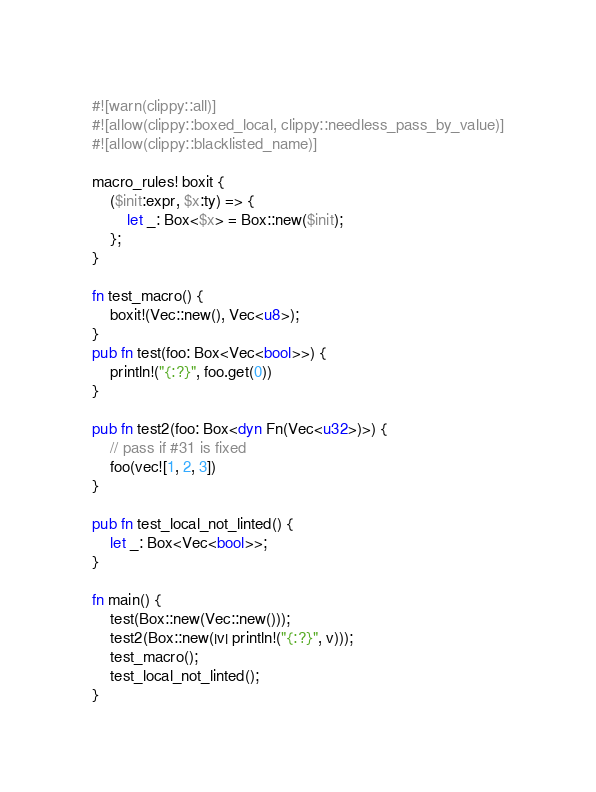Convert code to text. <code><loc_0><loc_0><loc_500><loc_500><_Rust_>#![warn(clippy::all)]
#![allow(clippy::boxed_local, clippy::needless_pass_by_value)]
#![allow(clippy::blacklisted_name)]

macro_rules! boxit {
    ($init:expr, $x:ty) => {
        let _: Box<$x> = Box::new($init);
    };
}

fn test_macro() {
    boxit!(Vec::new(), Vec<u8>);
}
pub fn test(foo: Box<Vec<bool>>) {
    println!("{:?}", foo.get(0))
}

pub fn test2(foo: Box<dyn Fn(Vec<u32>)>) {
    // pass if #31 is fixed
    foo(vec![1, 2, 3])
}

pub fn test_local_not_linted() {
    let _: Box<Vec<bool>>;
}

fn main() {
    test(Box::new(Vec::new()));
    test2(Box::new(|v| println!("{:?}", v)));
    test_macro();
    test_local_not_linted();
}
</code> 